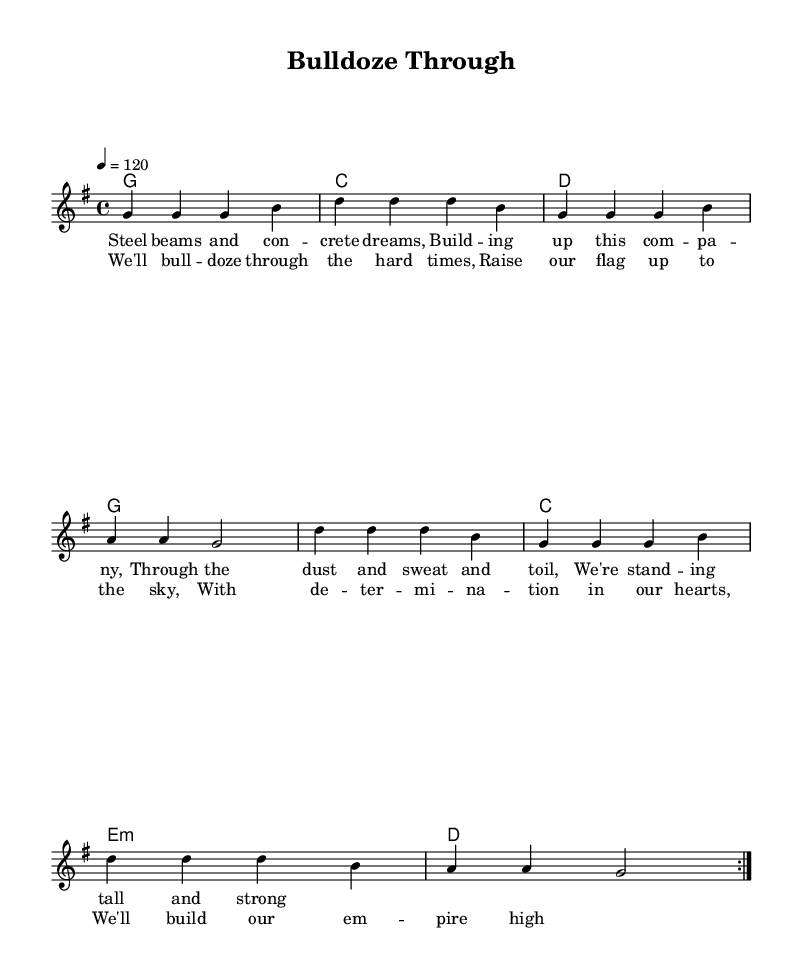What is the key signature of this music? The key signature is G major, which has one sharp, the F#. This is indicated by the presence of the G major scale in the melody and harmonies.
Answer: G major What is the time signature of this music? The time signature shown in the music is 4/4, which means there are four beats in each measure, and the quarter note gets one beat. This can be identified at the beginning of the score.
Answer: 4/4 What is the tempo marking of this music? The tempo marking indicates that the piece is played at a speed of 120 beats per minute. This is shown at the beginning of the score, alongside the time signature.
Answer: 120 What is the first phrase of the lyrics? The first phrase can be found in the lyric section, where the melody begins. It states “Steel beams and concrete dreams,” starting the narrative of building and struggle.
Answer: Steel beams and concrete dreams How many times is the melody repeated in this piece? The melody section indicates it is repeated twice, as specified by the notation "\repeat volta 2" which denotes that the section should be played two times.
Answer: 2 What is a central theme of the song? The lyrics and overall structure reflect themes of determination and overcoming obstacles in the construction business, emphasizing perseverance. This theme can be extracted from both the verses and the chorus.
Answer: Overcoming challenges What instrument is primarily featured in this music? The primary instrument is the lead voice indicated in the score under the "new Voice = 'lead'" notation. In country music, the vocal performance is typically central to conveying the song's message.
Answer: Voice 